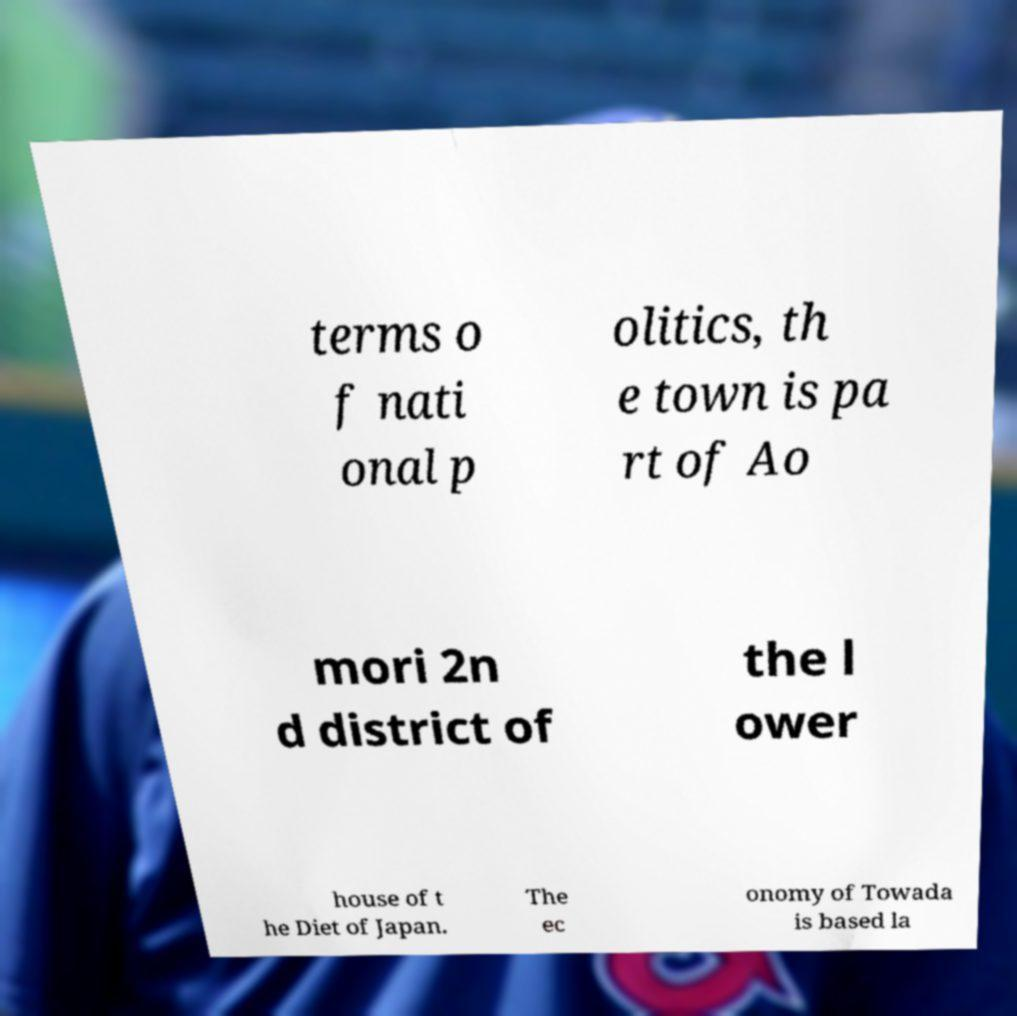Can you accurately transcribe the text from the provided image for me? terms o f nati onal p olitics, th e town is pa rt of Ao mori 2n d district of the l ower house of t he Diet of Japan. The ec onomy of Towada is based la 